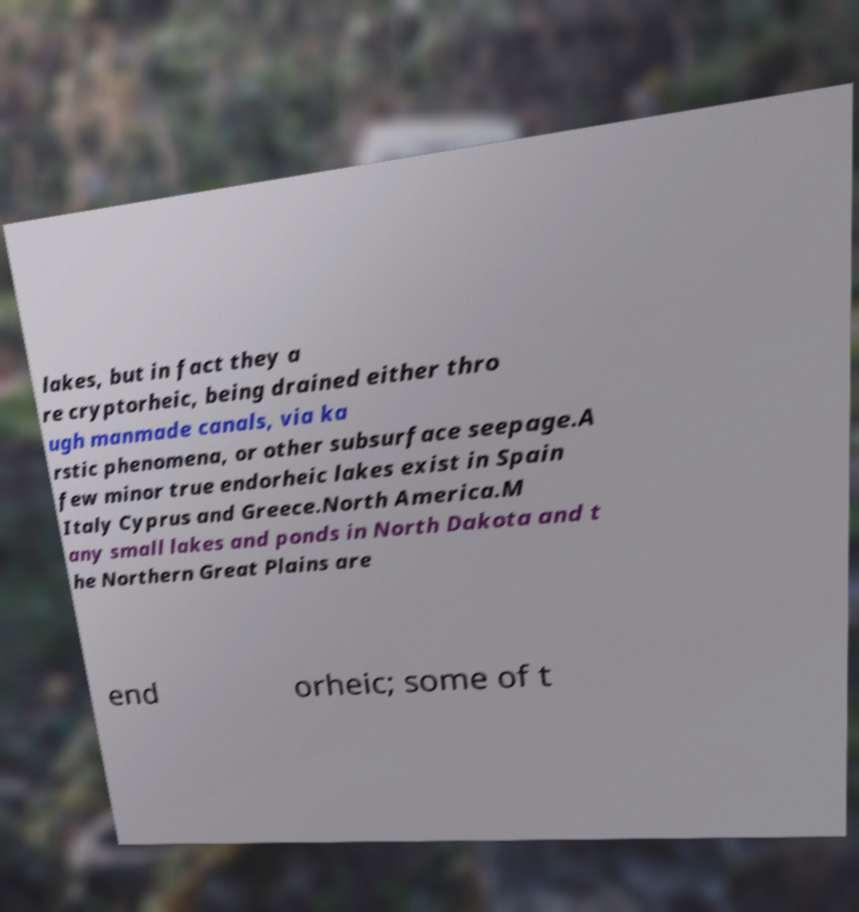Could you extract and type out the text from this image? lakes, but in fact they a re cryptorheic, being drained either thro ugh manmade canals, via ka rstic phenomena, or other subsurface seepage.A few minor true endorheic lakes exist in Spain Italy Cyprus and Greece.North America.M any small lakes and ponds in North Dakota and t he Northern Great Plains are end orheic; some of t 